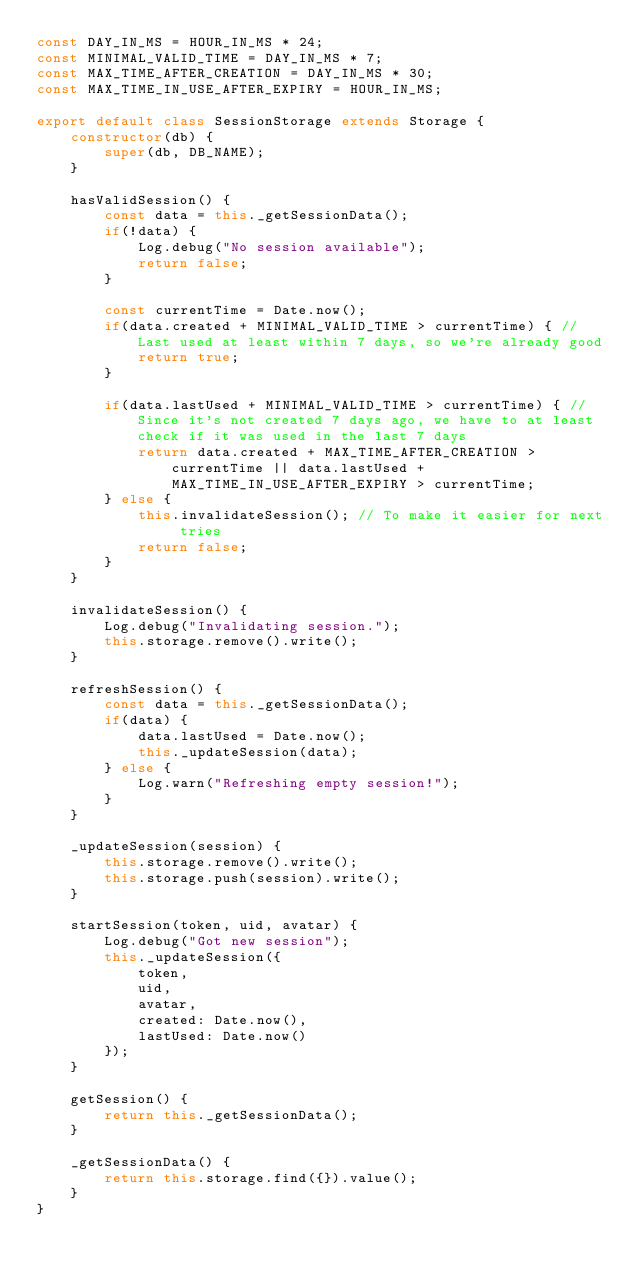<code> <loc_0><loc_0><loc_500><loc_500><_TypeScript_>const DAY_IN_MS = HOUR_IN_MS * 24;
const MINIMAL_VALID_TIME = DAY_IN_MS * 7;
const MAX_TIME_AFTER_CREATION = DAY_IN_MS * 30;
const MAX_TIME_IN_USE_AFTER_EXPIRY = HOUR_IN_MS;

export default class SessionStorage extends Storage {
    constructor(db) {
        super(db, DB_NAME);
    }

    hasValidSession() {
        const data = this._getSessionData();
        if(!data) {
            Log.debug("No session available");
            return false;
        }

        const currentTime = Date.now();
        if(data.created + MINIMAL_VALID_TIME > currentTime) { // Last used at least within 7 days, so we're already good
            return true;
        }

        if(data.lastUsed + MINIMAL_VALID_TIME > currentTime) { // Since it's not created 7 days ago, we have to at least check if it was used in the last 7 days
            return data.created + MAX_TIME_AFTER_CREATION > currentTime || data.lastUsed + MAX_TIME_IN_USE_AFTER_EXPIRY > currentTime;
        } else {
            this.invalidateSession(); // To make it easier for next tries
            return false;
        }
    }

    invalidateSession() {
        Log.debug("Invalidating session.");
        this.storage.remove().write();
    }

    refreshSession() {
        const data = this._getSessionData();
        if(data) {
            data.lastUsed = Date.now();
            this._updateSession(data);
        } else {
            Log.warn("Refreshing empty session!");
        }
    }

    _updateSession(session) {
        this.storage.remove().write();
        this.storage.push(session).write();
    }

    startSession(token, uid, avatar) {
        Log.debug("Got new session");
        this._updateSession({
            token,
            uid,
            avatar,
            created: Date.now(),
            lastUsed: Date.now()
        });
    }

    getSession() {
        return this._getSessionData();
    }

    _getSessionData() {
        return this.storage.find({}).value();
    }
}
</code> 